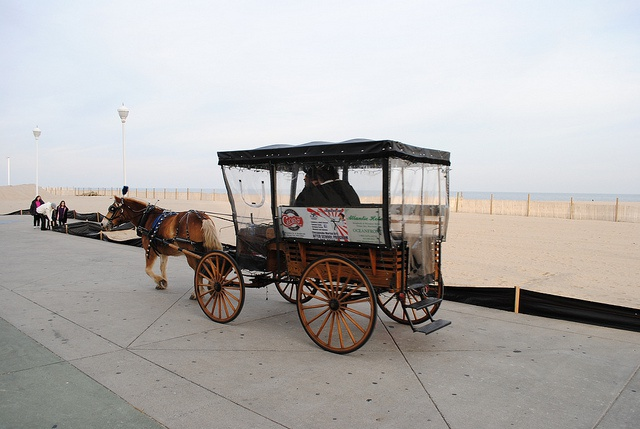Describe the objects in this image and their specific colors. I can see horse in lavender, black, maroon, darkgray, and gray tones, people in lavender, black, gray, maroon, and darkgray tones, people in lavender, lightgray, black, and darkgray tones, people in lavender, black, maroon, gray, and brown tones, and people in lavender, black, gray, darkgray, and magenta tones in this image. 